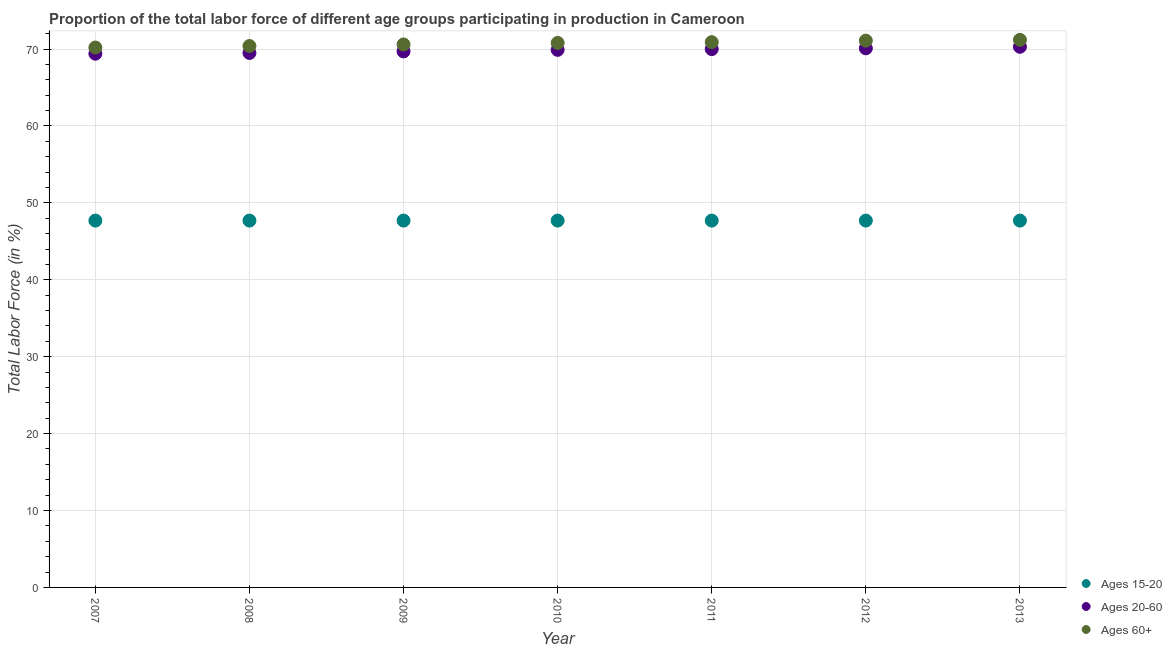How many different coloured dotlines are there?
Offer a very short reply. 3. What is the percentage of labor force above age 60 in 2012?
Make the answer very short. 71.1. Across all years, what is the maximum percentage of labor force above age 60?
Provide a short and direct response. 71.2. Across all years, what is the minimum percentage of labor force within the age group 15-20?
Your answer should be very brief. 47.7. In which year was the percentage of labor force above age 60 maximum?
Provide a short and direct response. 2013. In which year was the percentage of labor force within the age group 15-20 minimum?
Offer a very short reply. 2007. What is the total percentage of labor force above age 60 in the graph?
Offer a very short reply. 495.2. What is the difference between the percentage of labor force within the age group 15-20 in 2007 and that in 2012?
Your response must be concise. 0. What is the difference between the percentage of labor force above age 60 in 2011 and the percentage of labor force within the age group 15-20 in 2010?
Offer a very short reply. 23.2. What is the average percentage of labor force within the age group 15-20 per year?
Ensure brevity in your answer.  47.7. In the year 2011, what is the difference between the percentage of labor force within the age group 15-20 and percentage of labor force above age 60?
Keep it short and to the point. -23.2. What is the difference between the highest and the second highest percentage of labor force within the age group 20-60?
Keep it short and to the point. 0.2. What is the difference between the highest and the lowest percentage of labor force within the age group 15-20?
Keep it short and to the point. 0. In how many years, is the percentage of labor force above age 60 greater than the average percentage of labor force above age 60 taken over all years?
Offer a terse response. 4. Is it the case that in every year, the sum of the percentage of labor force within the age group 15-20 and percentage of labor force within the age group 20-60 is greater than the percentage of labor force above age 60?
Ensure brevity in your answer.  Yes. Does the percentage of labor force above age 60 monotonically increase over the years?
Offer a terse response. Yes. How many dotlines are there?
Make the answer very short. 3. Are the values on the major ticks of Y-axis written in scientific E-notation?
Offer a very short reply. No. Does the graph contain any zero values?
Give a very brief answer. No. Does the graph contain grids?
Ensure brevity in your answer.  Yes. Where does the legend appear in the graph?
Your answer should be very brief. Bottom right. How are the legend labels stacked?
Provide a short and direct response. Vertical. What is the title of the graph?
Provide a succinct answer. Proportion of the total labor force of different age groups participating in production in Cameroon. What is the label or title of the Y-axis?
Ensure brevity in your answer.  Total Labor Force (in %). What is the Total Labor Force (in %) of Ages 15-20 in 2007?
Keep it short and to the point. 47.7. What is the Total Labor Force (in %) of Ages 20-60 in 2007?
Offer a very short reply. 69.4. What is the Total Labor Force (in %) of Ages 60+ in 2007?
Your answer should be compact. 70.2. What is the Total Labor Force (in %) of Ages 15-20 in 2008?
Give a very brief answer. 47.7. What is the Total Labor Force (in %) in Ages 20-60 in 2008?
Provide a short and direct response. 69.5. What is the Total Labor Force (in %) in Ages 60+ in 2008?
Your answer should be compact. 70.4. What is the Total Labor Force (in %) of Ages 15-20 in 2009?
Keep it short and to the point. 47.7. What is the Total Labor Force (in %) of Ages 20-60 in 2009?
Provide a succinct answer. 69.7. What is the Total Labor Force (in %) of Ages 60+ in 2009?
Provide a short and direct response. 70.6. What is the Total Labor Force (in %) in Ages 15-20 in 2010?
Make the answer very short. 47.7. What is the Total Labor Force (in %) of Ages 20-60 in 2010?
Ensure brevity in your answer.  69.9. What is the Total Labor Force (in %) in Ages 60+ in 2010?
Ensure brevity in your answer.  70.8. What is the Total Labor Force (in %) of Ages 15-20 in 2011?
Offer a terse response. 47.7. What is the Total Labor Force (in %) of Ages 60+ in 2011?
Ensure brevity in your answer.  70.9. What is the Total Labor Force (in %) of Ages 15-20 in 2012?
Provide a short and direct response. 47.7. What is the Total Labor Force (in %) in Ages 20-60 in 2012?
Offer a very short reply. 70.1. What is the Total Labor Force (in %) of Ages 60+ in 2012?
Your answer should be very brief. 71.1. What is the Total Labor Force (in %) of Ages 15-20 in 2013?
Give a very brief answer. 47.7. What is the Total Labor Force (in %) in Ages 20-60 in 2013?
Ensure brevity in your answer.  70.3. What is the Total Labor Force (in %) in Ages 60+ in 2013?
Your answer should be very brief. 71.2. Across all years, what is the maximum Total Labor Force (in %) of Ages 15-20?
Ensure brevity in your answer.  47.7. Across all years, what is the maximum Total Labor Force (in %) in Ages 20-60?
Provide a short and direct response. 70.3. Across all years, what is the maximum Total Labor Force (in %) of Ages 60+?
Your answer should be very brief. 71.2. Across all years, what is the minimum Total Labor Force (in %) in Ages 15-20?
Keep it short and to the point. 47.7. Across all years, what is the minimum Total Labor Force (in %) in Ages 20-60?
Offer a very short reply. 69.4. Across all years, what is the minimum Total Labor Force (in %) of Ages 60+?
Make the answer very short. 70.2. What is the total Total Labor Force (in %) of Ages 15-20 in the graph?
Ensure brevity in your answer.  333.9. What is the total Total Labor Force (in %) in Ages 20-60 in the graph?
Offer a very short reply. 488.9. What is the total Total Labor Force (in %) of Ages 60+ in the graph?
Ensure brevity in your answer.  495.2. What is the difference between the Total Labor Force (in %) of Ages 15-20 in 2007 and that in 2008?
Your answer should be very brief. 0. What is the difference between the Total Labor Force (in %) in Ages 60+ in 2007 and that in 2008?
Your response must be concise. -0.2. What is the difference between the Total Labor Force (in %) of Ages 60+ in 2007 and that in 2009?
Your answer should be very brief. -0.4. What is the difference between the Total Labor Force (in %) of Ages 20-60 in 2007 and that in 2010?
Give a very brief answer. -0.5. What is the difference between the Total Labor Force (in %) of Ages 60+ in 2007 and that in 2011?
Ensure brevity in your answer.  -0.7. What is the difference between the Total Labor Force (in %) of Ages 60+ in 2007 and that in 2013?
Give a very brief answer. -1. What is the difference between the Total Labor Force (in %) in Ages 15-20 in 2008 and that in 2009?
Provide a succinct answer. 0. What is the difference between the Total Labor Force (in %) of Ages 20-60 in 2008 and that in 2009?
Ensure brevity in your answer.  -0.2. What is the difference between the Total Labor Force (in %) of Ages 60+ in 2008 and that in 2009?
Make the answer very short. -0.2. What is the difference between the Total Labor Force (in %) in Ages 20-60 in 2008 and that in 2010?
Give a very brief answer. -0.4. What is the difference between the Total Labor Force (in %) of Ages 60+ in 2008 and that in 2010?
Offer a terse response. -0.4. What is the difference between the Total Labor Force (in %) of Ages 20-60 in 2008 and that in 2012?
Make the answer very short. -0.6. What is the difference between the Total Labor Force (in %) in Ages 15-20 in 2008 and that in 2013?
Give a very brief answer. 0. What is the difference between the Total Labor Force (in %) of Ages 20-60 in 2008 and that in 2013?
Make the answer very short. -0.8. What is the difference between the Total Labor Force (in %) of Ages 60+ in 2008 and that in 2013?
Give a very brief answer. -0.8. What is the difference between the Total Labor Force (in %) of Ages 20-60 in 2009 and that in 2010?
Your response must be concise. -0.2. What is the difference between the Total Labor Force (in %) in Ages 60+ in 2009 and that in 2012?
Provide a succinct answer. -0.5. What is the difference between the Total Labor Force (in %) of Ages 15-20 in 2009 and that in 2013?
Your response must be concise. 0. What is the difference between the Total Labor Force (in %) of Ages 20-60 in 2009 and that in 2013?
Provide a short and direct response. -0.6. What is the difference between the Total Labor Force (in %) in Ages 15-20 in 2010 and that in 2011?
Your answer should be compact. 0. What is the difference between the Total Labor Force (in %) of Ages 60+ in 2010 and that in 2011?
Provide a short and direct response. -0.1. What is the difference between the Total Labor Force (in %) of Ages 60+ in 2010 and that in 2012?
Your answer should be very brief. -0.3. What is the difference between the Total Labor Force (in %) of Ages 20-60 in 2010 and that in 2013?
Your answer should be compact. -0.4. What is the difference between the Total Labor Force (in %) of Ages 60+ in 2010 and that in 2013?
Provide a short and direct response. -0.4. What is the difference between the Total Labor Force (in %) in Ages 15-20 in 2011 and that in 2012?
Your answer should be compact. 0. What is the difference between the Total Labor Force (in %) of Ages 20-60 in 2011 and that in 2012?
Provide a short and direct response. -0.1. What is the difference between the Total Labor Force (in %) of Ages 20-60 in 2011 and that in 2013?
Offer a terse response. -0.3. What is the difference between the Total Labor Force (in %) of Ages 15-20 in 2012 and that in 2013?
Your answer should be compact. 0. What is the difference between the Total Labor Force (in %) of Ages 20-60 in 2012 and that in 2013?
Keep it short and to the point. -0.2. What is the difference between the Total Labor Force (in %) of Ages 60+ in 2012 and that in 2013?
Give a very brief answer. -0.1. What is the difference between the Total Labor Force (in %) in Ages 15-20 in 2007 and the Total Labor Force (in %) in Ages 20-60 in 2008?
Give a very brief answer. -21.8. What is the difference between the Total Labor Force (in %) in Ages 15-20 in 2007 and the Total Labor Force (in %) in Ages 60+ in 2008?
Give a very brief answer. -22.7. What is the difference between the Total Labor Force (in %) in Ages 15-20 in 2007 and the Total Labor Force (in %) in Ages 60+ in 2009?
Your answer should be compact. -22.9. What is the difference between the Total Labor Force (in %) of Ages 15-20 in 2007 and the Total Labor Force (in %) of Ages 20-60 in 2010?
Your answer should be compact. -22.2. What is the difference between the Total Labor Force (in %) in Ages 15-20 in 2007 and the Total Labor Force (in %) in Ages 60+ in 2010?
Provide a short and direct response. -23.1. What is the difference between the Total Labor Force (in %) in Ages 20-60 in 2007 and the Total Labor Force (in %) in Ages 60+ in 2010?
Provide a succinct answer. -1.4. What is the difference between the Total Labor Force (in %) of Ages 15-20 in 2007 and the Total Labor Force (in %) of Ages 20-60 in 2011?
Your answer should be very brief. -22.3. What is the difference between the Total Labor Force (in %) in Ages 15-20 in 2007 and the Total Labor Force (in %) in Ages 60+ in 2011?
Ensure brevity in your answer.  -23.2. What is the difference between the Total Labor Force (in %) in Ages 15-20 in 2007 and the Total Labor Force (in %) in Ages 20-60 in 2012?
Provide a short and direct response. -22.4. What is the difference between the Total Labor Force (in %) in Ages 15-20 in 2007 and the Total Labor Force (in %) in Ages 60+ in 2012?
Your response must be concise. -23.4. What is the difference between the Total Labor Force (in %) of Ages 15-20 in 2007 and the Total Labor Force (in %) of Ages 20-60 in 2013?
Offer a terse response. -22.6. What is the difference between the Total Labor Force (in %) of Ages 15-20 in 2007 and the Total Labor Force (in %) of Ages 60+ in 2013?
Make the answer very short. -23.5. What is the difference between the Total Labor Force (in %) in Ages 15-20 in 2008 and the Total Labor Force (in %) in Ages 60+ in 2009?
Offer a very short reply. -22.9. What is the difference between the Total Labor Force (in %) of Ages 15-20 in 2008 and the Total Labor Force (in %) of Ages 20-60 in 2010?
Provide a short and direct response. -22.2. What is the difference between the Total Labor Force (in %) of Ages 15-20 in 2008 and the Total Labor Force (in %) of Ages 60+ in 2010?
Your answer should be compact. -23.1. What is the difference between the Total Labor Force (in %) of Ages 20-60 in 2008 and the Total Labor Force (in %) of Ages 60+ in 2010?
Your answer should be compact. -1.3. What is the difference between the Total Labor Force (in %) in Ages 15-20 in 2008 and the Total Labor Force (in %) in Ages 20-60 in 2011?
Your answer should be compact. -22.3. What is the difference between the Total Labor Force (in %) in Ages 15-20 in 2008 and the Total Labor Force (in %) in Ages 60+ in 2011?
Offer a terse response. -23.2. What is the difference between the Total Labor Force (in %) in Ages 20-60 in 2008 and the Total Labor Force (in %) in Ages 60+ in 2011?
Make the answer very short. -1.4. What is the difference between the Total Labor Force (in %) of Ages 15-20 in 2008 and the Total Labor Force (in %) of Ages 20-60 in 2012?
Give a very brief answer. -22.4. What is the difference between the Total Labor Force (in %) in Ages 15-20 in 2008 and the Total Labor Force (in %) in Ages 60+ in 2012?
Keep it short and to the point. -23.4. What is the difference between the Total Labor Force (in %) of Ages 15-20 in 2008 and the Total Labor Force (in %) of Ages 20-60 in 2013?
Make the answer very short. -22.6. What is the difference between the Total Labor Force (in %) in Ages 15-20 in 2008 and the Total Labor Force (in %) in Ages 60+ in 2013?
Ensure brevity in your answer.  -23.5. What is the difference between the Total Labor Force (in %) in Ages 15-20 in 2009 and the Total Labor Force (in %) in Ages 20-60 in 2010?
Provide a short and direct response. -22.2. What is the difference between the Total Labor Force (in %) of Ages 15-20 in 2009 and the Total Labor Force (in %) of Ages 60+ in 2010?
Your answer should be very brief. -23.1. What is the difference between the Total Labor Force (in %) of Ages 20-60 in 2009 and the Total Labor Force (in %) of Ages 60+ in 2010?
Your response must be concise. -1.1. What is the difference between the Total Labor Force (in %) of Ages 15-20 in 2009 and the Total Labor Force (in %) of Ages 20-60 in 2011?
Offer a terse response. -22.3. What is the difference between the Total Labor Force (in %) of Ages 15-20 in 2009 and the Total Labor Force (in %) of Ages 60+ in 2011?
Ensure brevity in your answer.  -23.2. What is the difference between the Total Labor Force (in %) in Ages 20-60 in 2009 and the Total Labor Force (in %) in Ages 60+ in 2011?
Your answer should be very brief. -1.2. What is the difference between the Total Labor Force (in %) in Ages 15-20 in 2009 and the Total Labor Force (in %) in Ages 20-60 in 2012?
Your answer should be compact. -22.4. What is the difference between the Total Labor Force (in %) in Ages 15-20 in 2009 and the Total Labor Force (in %) in Ages 60+ in 2012?
Provide a short and direct response. -23.4. What is the difference between the Total Labor Force (in %) in Ages 15-20 in 2009 and the Total Labor Force (in %) in Ages 20-60 in 2013?
Keep it short and to the point. -22.6. What is the difference between the Total Labor Force (in %) in Ages 15-20 in 2009 and the Total Labor Force (in %) in Ages 60+ in 2013?
Provide a succinct answer. -23.5. What is the difference between the Total Labor Force (in %) in Ages 15-20 in 2010 and the Total Labor Force (in %) in Ages 20-60 in 2011?
Ensure brevity in your answer.  -22.3. What is the difference between the Total Labor Force (in %) in Ages 15-20 in 2010 and the Total Labor Force (in %) in Ages 60+ in 2011?
Keep it short and to the point. -23.2. What is the difference between the Total Labor Force (in %) of Ages 20-60 in 2010 and the Total Labor Force (in %) of Ages 60+ in 2011?
Your response must be concise. -1. What is the difference between the Total Labor Force (in %) of Ages 15-20 in 2010 and the Total Labor Force (in %) of Ages 20-60 in 2012?
Offer a terse response. -22.4. What is the difference between the Total Labor Force (in %) in Ages 15-20 in 2010 and the Total Labor Force (in %) in Ages 60+ in 2012?
Your answer should be very brief. -23.4. What is the difference between the Total Labor Force (in %) in Ages 20-60 in 2010 and the Total Labor Force (in %) in Ages 60+ in 2012?
Give a very brief answer. -1.2. What is the difference between the Total Labor Force (in %) of Ages 15-20 in 2010 and the Total Labor Force (in %) of Ages 20-60 in 2013?
Your answer should be compact. -22.6. What is the difference between the Total Labor Force (in %) of Ages 15-20 in 2010 and the Total Labor Force (in %) of Ages 60+ in 2013?
Offer a terse response. -23.5. What is the difference between the Total Labor Force (in %) of Ages 20-60 in 2010 and the Total Labor Force (in %) of Ages 60+ in 2013?
Make the answer very short. -1.3. What is the difference between the Total Labor Force (in %) of Ages 15-20 in 2011 and the Total Labor Force (in %) of Ages 20-60 in 2012?
Offer a terse response. -22.4. What is the difference between the Total Labor Force (in %) in Ages 15-20 in 2011 and the Total Labor Force (in %) in Ages 60+ in 2012?
Offer a very short reply. -23.4. What is the difference between the Total Labor Force (in %) of Ages 15-20 in 2011 and the Total Labor Force (in %) of Ages 20-60 in 2013?
Your answer should be very brief. -22.6. What is the difference between the Total Labor Force (in %) of Ages 15-20 in 2011 and the Total Labor Force (in %) of Ages 60+ in 2013?
Your response must be concise. -23.5. What is the difference between the Total Labor Force (in %) in Ages 15-20 in 2012 and the Total Labor Force (in %) in Ages 20-60 in 2013?
Keep it short and to the point. -22.6. What is the difference between the Total Labor Force (in %) in Ages 15-20 in 2012 and the Total Labor Force (in %) in Ages 60+ in 2013?
Keep it short and to the point. -23.5. What is the average Total Labor Force (in %) in Ages 15-20 per year?
Keep it short and to the point. 47.7. What is the average Total Labor Force (in %) in Ages 20-60 per year?
Ensure brevity in your answer.  69.84. What is the average Total Labor Force (in %) in Ages 60+ per year?
Provide a succinct answer. 70.74. In the year 2007, what is the difference between the Total Labor Force (in %) of Ages 15-20 and Total Labor Force (in %) of Ages 20-60?
Provide a short and direct response. -21.7. In the year 2007, what is the difference between the Total Labor Force (in %) of Ages 15-20 and Total Labor Force (in %) of Ages 60+?
Make the answer very short. -22.5. In the year 2007, what is the difference between the Total Labor Force (in %) of Ages 20-60 and Total Labor Force (in %) of Ages 60+?
Your response must be concise. -0.8. In the year 2008, what is the difference between the Total Labor Force (in %) in Ages 15-20 and Total Labor Force (in %) in Ages 20-60?
Ensure brevity in your answer.  -21.8. In the year 2008, what is the difference between the Total Labor Force (in %) in Ages 15-20 and Total Labor Force (in %) in Ages 60+?
Offer a very short reply. -22.7. In the year 2009, what is the difference between the Total Labor Force (in %) in Ages 15-20 and Total Labor Force (in %) in Ages 60+?
Offer a terse response. -22.9. In the year 2009, what is the difference between the Total Labor Force (in %) in Ages 20-60 and Total Labor Force (in %) in Ages 60+?
Offer a terse response. -0.9. In the year 2010, what is the difference between the Total Labor Force (in %) in Ages 15-20 and Total Labor Force (in %) in Ages 20-60?
Offer a very short reply. -22.2. In the year 2010, what is the difference between the Total Labor Force (in %) of Ages 15-20 and Total Labor Force (in %) of Ages 60+?
Offer a very short reply. -23.1. In the year 2010, what is the difference between the Total Labor Force (in %) of Ages 20-60 and Total Labor Force (in %) of Ages 60+?
Your response must be concise. -0.9. In the year 2011, what is the difference between the Total Labor Force (in %) of Ages 15-20 and Total Labor Force (in %) of Ages 20-60?
Offer a terse response. -22.3. In the year 2011, what is the difference between the Total Labor Force (in %) in Ages 15-20 and Total Labor Force (in %) in Ages 60+?
Provide a short and direct response. -23.2. In the year 2011, what is the difference between the Total Labor Force (in %) of Ages 20-60 and Total Labor Force (in %) of Ages 60+?
Provide a succinct answer. -0.9. In the year 2012, what is the difference between the Total Labor Force (in %) in Ages 15-20 and Total Labor Force (in %) in Ages 20-60?
Provide a short and direct response. -22.4. In the year 2012, what is the difference between the Total Labor Force (in %) in Ages 15-20 and Total Labor Force (in %) in Ages 60+?
Your answer should be compact. -23.4. In the year 2012, what is the difference between the Total Labor Force (in %) in Ages 20-60 and Total Labor Force (in %) in Ages 60+?
Your response must be concise. -1. In the year 2013, what is the difference between the Total Labor Force (in %) of Ages 15-20 and Total Labor Force (in %) of Ages 20-60?
Give a very brief answer. -22.6. In the year 2013, what is the difference between the Total Labor Force (in %) in Ages 15-20 and Total Labor Force (in %) in Ages 60+?
Your response must be concise. -23.5. What is the ratio of the Total Labor Force (in %) in Ages 60+ in 2007 to that in 2008?
Provide a short and direct response. 1. What is the ratio of the Total Labor Force (in %) in Ages 20-60 in 2007 to that in 2009?
Make the answer very short. 1. What is the ratio of the Total Labor Force (in %) in Ages 15-20 in 2007 to that in 2010?
Ensure brevity in your answer.  1. What is the ratio of the Total Labor Force (in %) of Ages 60+ in 2007 to that in 2010?
Your response must be concise. 0.99. What is the ratio of the Total Labor Force (in %) in Ages 20-60 in 2007 to that in 2011?
Make the answer very short. 0.99. What is the ratio of the Total Labor Force (in %) in Ages 60+ in 2007 to that in 2011?
Offer a very short reply. 0.99. What is the ratio of the Total Labor Force (in %) of Ages 60+ in 2007 to that in 2012?
Your answer should be very brief. 0.99. What is the ratio of the Total Labor Force (in %) in Ages 15-20 in 2007 to that in 2013?
Your response must be concise. 1. What is the ratio of the Total Labor Force (in %) in Ages 20-60 in 2007 to that in 2013?
Offer a terse response. 0.99. What is the ratio of the Total Labor Force (in %) of Ages 60+ in 2007 to that in 2013?
Provide a short and direct response. 0.99. What is the ratio of the Total Labor Force (in %) in Ages 15-20 in 2008 to that in 2010?
Make the answer very short. 1. What is the ratio of the Total Labor Force (in %) in Ages 20-60 in 2008 to that in 2010?
Offer a terse response. 0.99. What is the ratio of the Total Labor Force (in %) in Ages 60+ in 2008 to that in 2010?
Your response must be concise. 0.99. What is the ratio of the Total Labor Force (in %) of Ages 15-20 in 2008 to that in 2012?
Provide a succinct answer. 1. What is the ratio of the Total Labor Force (in %) in Ages 20-60 in 2008 to that in 2012?
Offer a very short reply. 0.99. What is the ratio of the Total Labor Force (in %) of Ages 60+ in 2008 to that in 2012?
Offer a very short reply. 0.99. What is the ratio of the Total Labor Force (in %) of Ages 20-60 in 2008 to that in 2013?
Ensure brevity in your answer.  0.99. What is the ratio of the Total Labor Force (in %) of Ages 60+ in 2008 to that in 2013?
Offer a terse response. 0.99. What is the ratio of the Total Labor Force (in %) in Ages 15-20 in 2009 to that in 2012?
Offer a very short reply. 1. What is the ratio of the Total Labor Force (in %) of Ages 20-60 in 2009 to that in 2012?
Make the answer very short. 0.99. What is the ratio of the Total Labor Force (in %) in Ages 60+ in 2009 to that in 2012?
Ensure brevity in your answer.  0.99. What is the ratio of the Total Labor Force (in %) of Ages 60+ in 2009 to that in 2013?
Give a very brief answer. 0.99. What is the ratio of the Total Labor Force (in %) of Ages 20-60 in 2010 to that in 2011?
Ensure brevity in your answer.  1. What is the ratio of the Total Labor Force (in %) in Ages 60+ in 2010 to that in 2011?
Your response must be concise. 1. What is the ratio of the Total Labor Force (in %) of Ages 20-60 in 2010 to that in 2012?
Make the answer very short. 1. What is the ratio of the Total Labor Force (in %) of Ages 60+ in 2010 to that in 2012?
Offer a very short reply. 1. What is the ratio of the Total Labor Force (in %) of Ages 20-60 in 2010 to that in 2013?
Offer a terse response. 0.99. What is the ratio of the Total Labor Force (in %) of Ages 60+ in 2010 to that in 2013?
Make the answer very short. 0.99. What is the ratio of the Total Labor Force (in %) of Ages 15-20 in 2011 to that in 2012?
Your answer should be very brief. 1. What is the ratio of the Total Labor Force (in %) of Ages 15-20 in 2011 to that in 2013?
Provide a succinct answer. 1. What is the ratio of the Total Labor Force (in %) of Ages 20-60 in 2011 to that in 2013?
Your response must be concise. 1. What is the ratio of the Total Labor Force (in %) of Ages 60+ in 2012 to that in 2013?
Provide a short and direct response. 1. What is the difference between the highest and the lowest Total Labor Force (in %) in Ages 60+?
Offer a terse response. 1. 